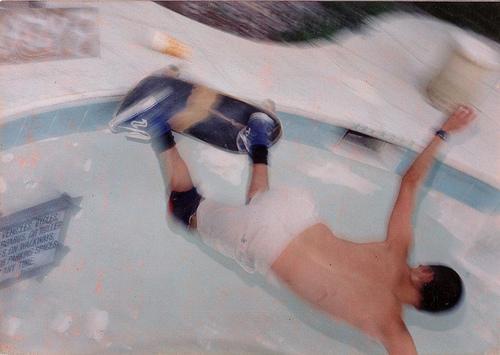How many pockets?
Give a very brief answer. 1. 